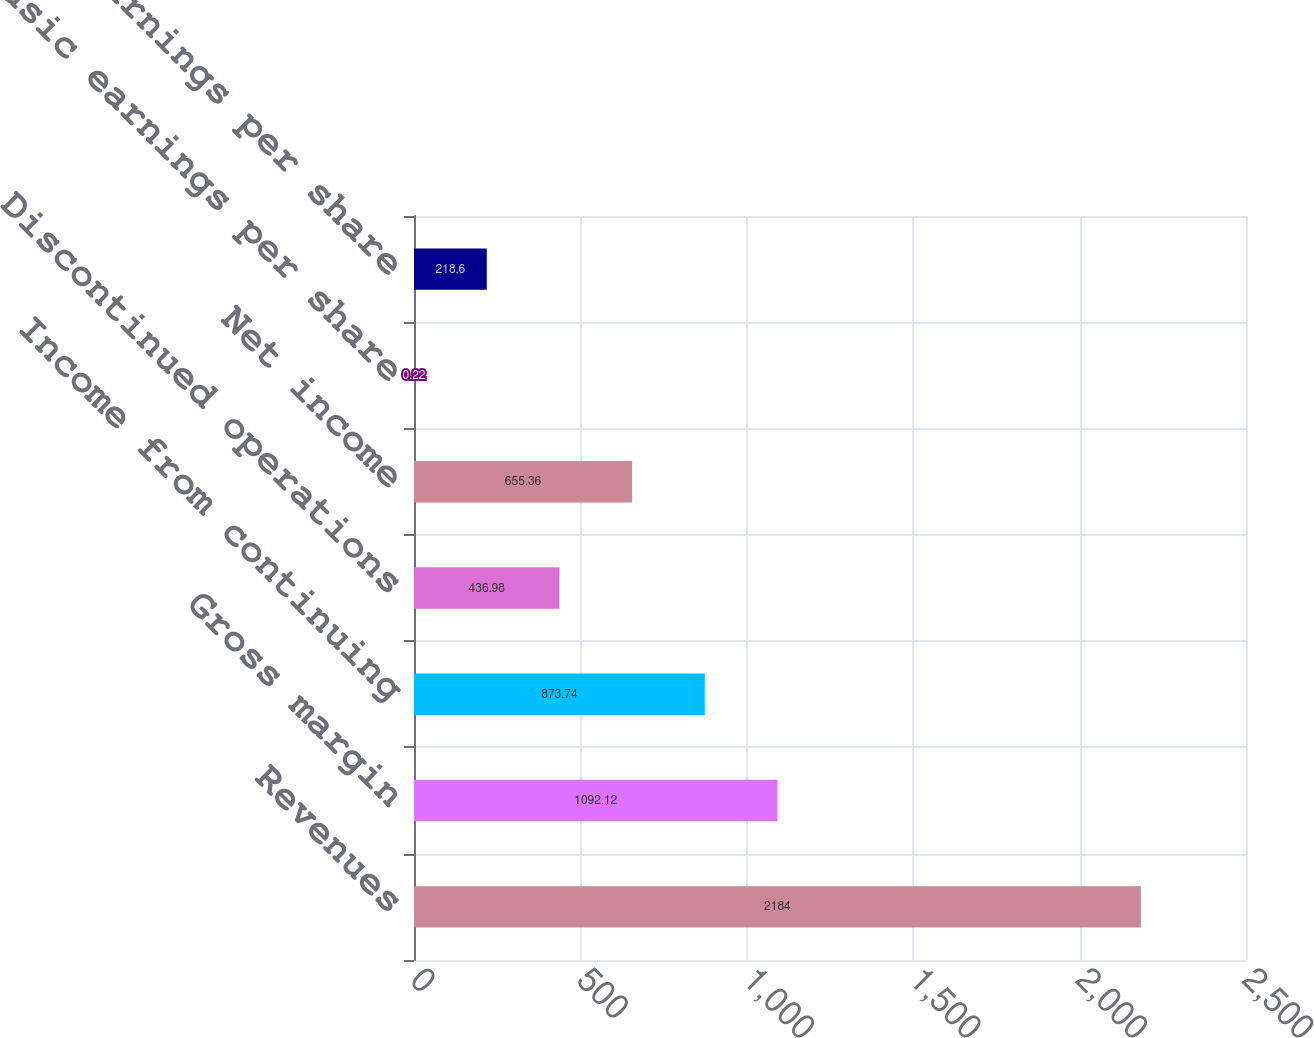Convert chart to OTSL. <chart><loc_0><loc_0><loc_500><loc_500><bar_chart><fcel>Revenues<fcel>Gross margin<fcel>Income from continuing<fcel>Discontinued operations<fcel>Net income<fcel>Basic earnings per share<fcel>Diluted earnings per share<nl><fcel>2184<fcel>1092.12<fcel>873.74<fcel>436.98<fcel>655.36<fcel>0.22<fcel>218.6<nl></chart> 